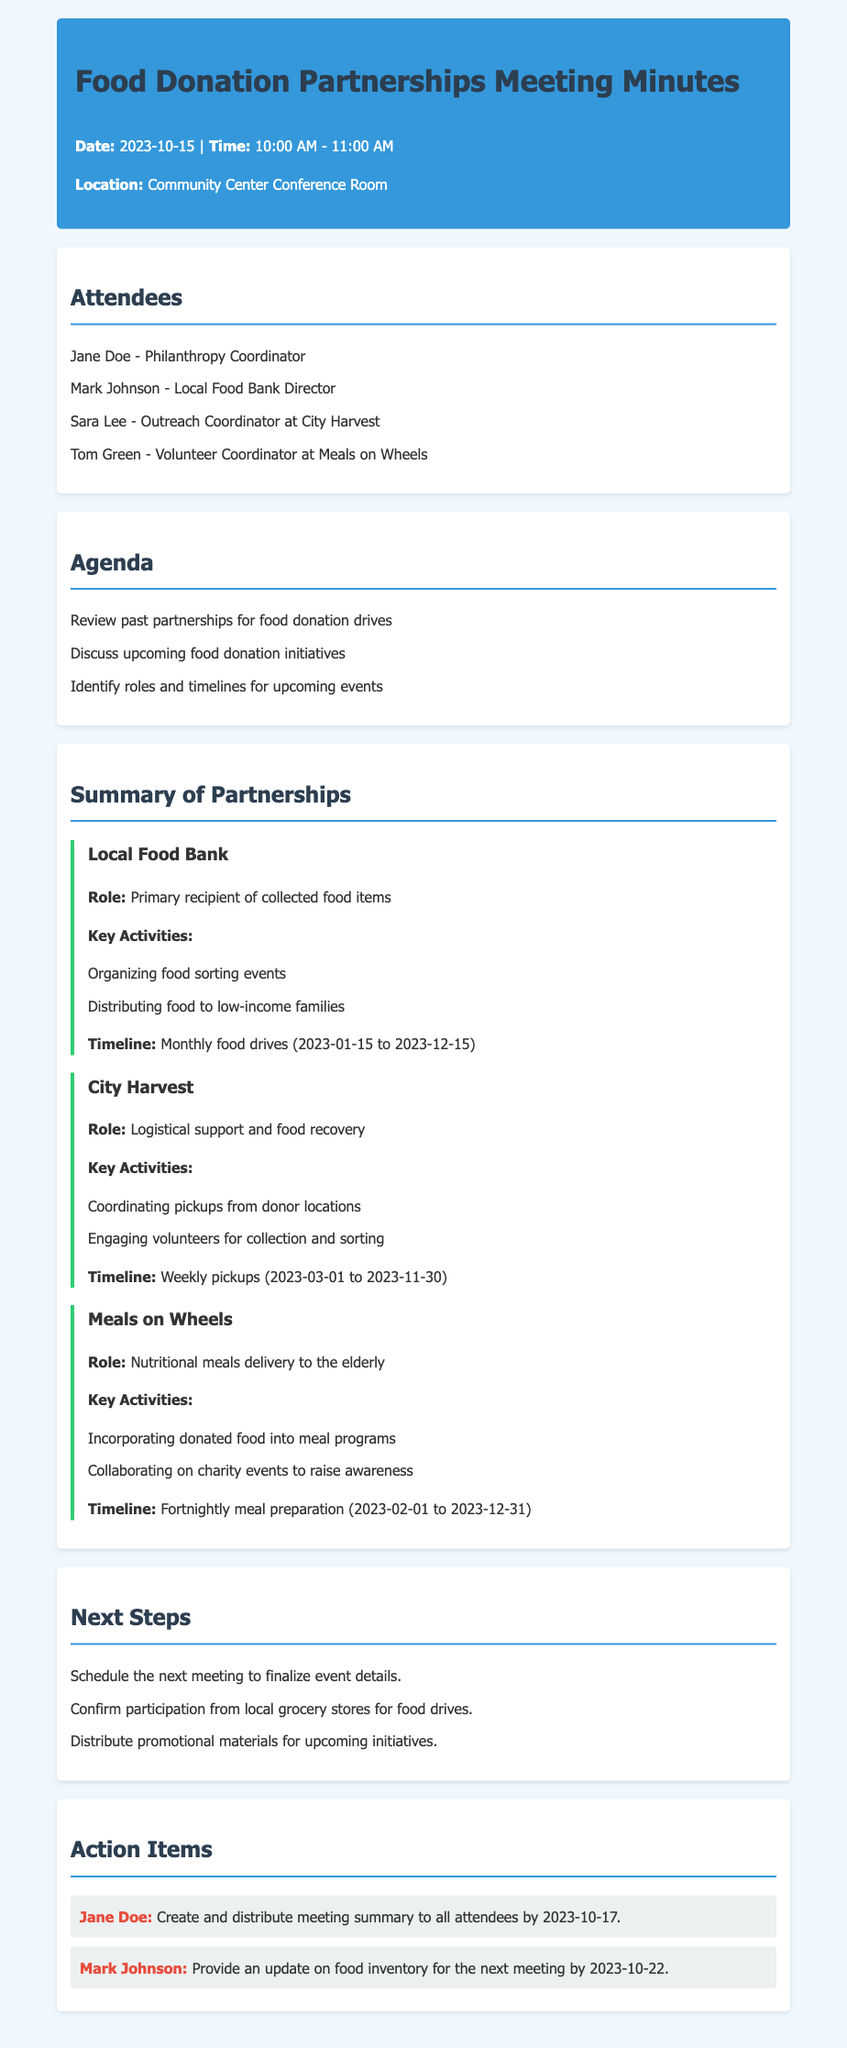what is the date of the meeting? The date of the meeting is stated in the header of the document.
Answer: 2023-10-15 who is the Philanthropy Coordinator? The Philanthropy Coordinator is listed among the attendees in the meeting minutes.
Answer: Jane Doe how long are the food drives with the Local Food Bank scheduled? The duration of the food drives is mentioned in relation to the timeline specified in the summary of partnerships.
Answer: Monthly food drives (2023-01-15 to 2023-12-15) what role does City Harvest play in the partnerships? The role of City Harvest is outlined in the summary of partnerships section of the document.
Answer: Logistical support and food recovery when is the next action item due from Mark Johnson? The due date for Mark Johnson's action item is specified in the action items section.
Answer: 2023-10-22 what is the format of the meeting minutes? The format includes attendees, agenda, summary of partnerships, next steps, and action items, which are typical for meeting minutes.
Answer: Meeting minutes how frequently does Meals on Wheels prepare meals according to the timeline? The frequency of meal preparations is described in the timeline section of the summary of partnerships.
Answer: Fortnightly meal preparation what should Jane Doe do after the meeting? The action item assigned to Jane Doe provides specific responsibilities she is to complete.
Answer: Create and distribute meeting summary to all attendees by 2023-10-17 